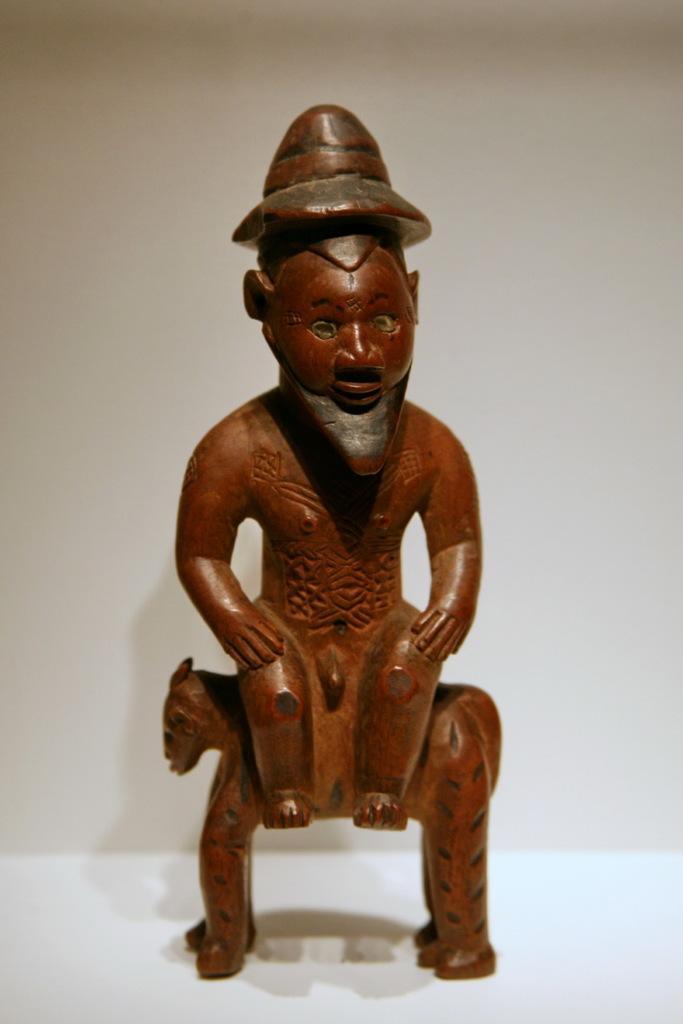Please provide a concise description of this image. In the center of the image we can see a toy sculpture. In the background there is a wall. 